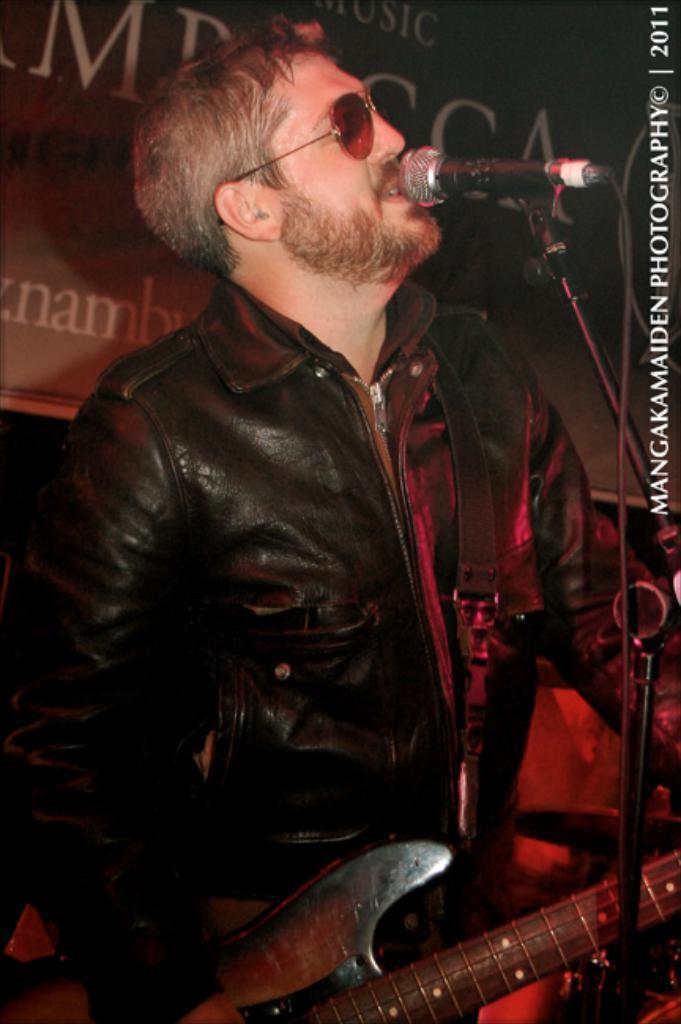Please provide a concise description of this image. He is standing. He is wearing a spectacle. He is holding a guitar. He is singing a song. We can see in background banner. 